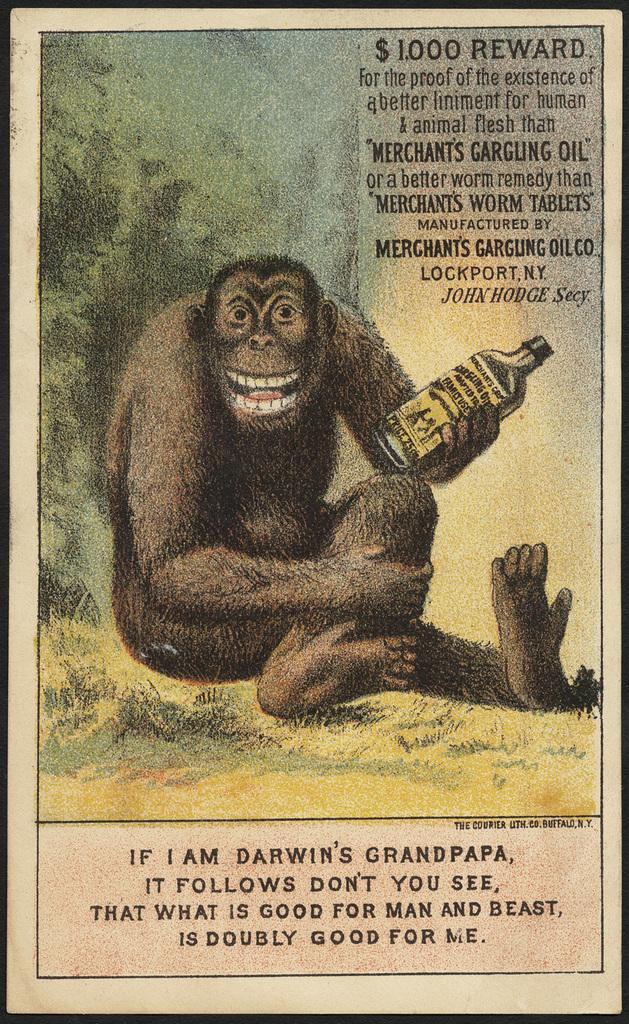How would you summarize this image in a sentence or two? In this image, we can see a poster with some image and text written. 